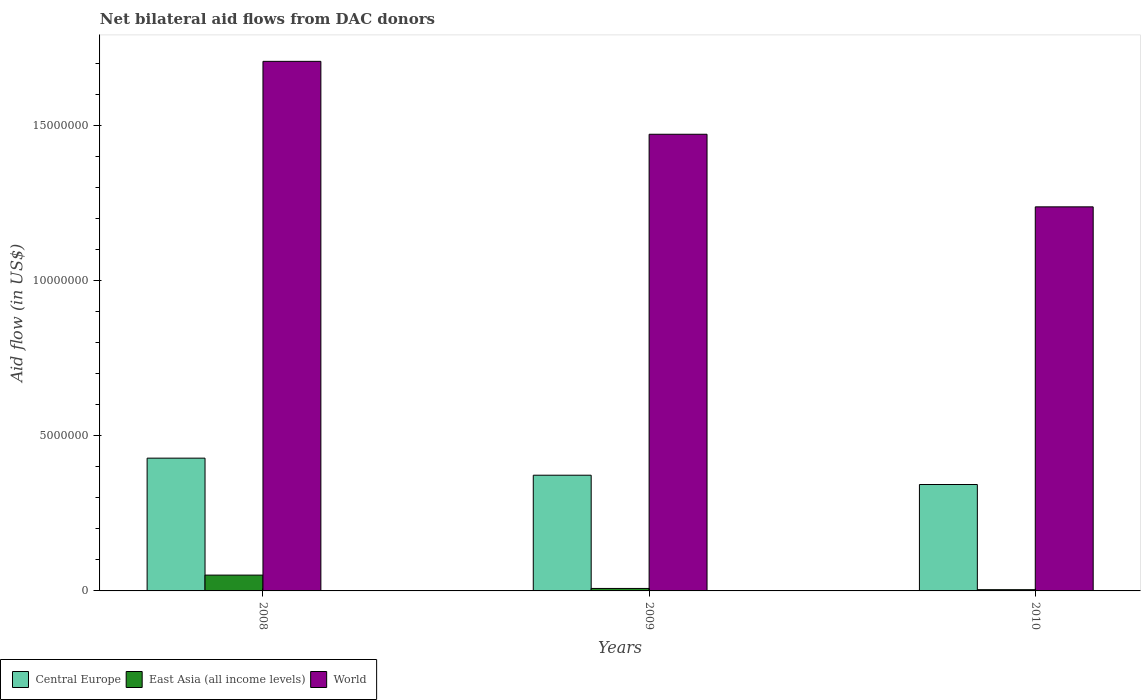How many different coloured bars are there?
Your response must be concise. 3. How many groups of bars are there?
Provide a succinct answer. 3. Are the number of bars per tick equal to the number of legend labels?
Give a very brief answer. Yes. Are the number of bars on each tick of the X-axis equal?
Make the answer very short. Yes. How many bars are there on the 3rd tick from the right?
Your response must be concise. 3. What is the label of the 2nd group of bars from the left?
Your answer should be very brief. 2009. What is the net bilateral aid flow in East Asia (all income levels) in 2008?
Keep it short and to the point. 5.10e+05. Across all years, what is the maximum net bilateral aid flow in Central Europe?
Provide a short and direct response. 4.28e+06. Across all years, what is the minimum net bilateral aid flow in East Asia (all income levels)?
Offer a very short reply. 4.00e+04. What is the total net bilateral aid flow in East Asia (all income levels) in the graph?
Offer a terse response. 6.30e+05. What is the difference between the net bilateral aid flow in Central Europe in 2009 and that in 2010?
Offer a very short reply. 3.00e+05. What is the difference between the net bilateral aid flow in Central Europe in 2010 and the net bilateral aid flow in World in 2009?
Your answer should be very brief. -1.13e+07. In the year 2009, what is the difference between the net bilateral aid flow in World and net bilateral aid flow in Central Europe?
Provide a short and direct response. 1.10e+07. In how many years, is the net bilateral aid flow in World greater than 2000000 US$?
Provide a succinct answer. 3. What is the ratio of the net bilateral aid flow in Central Europe in 2008 to that in 2009?
Offer a very short reply. 1.15. What is the difference between the highest and the second highest net bilateral aid flow in Central Europe?
Ensure brevity in your answer.  5.50e+05. What is the difference between the highest and the lowest net bilateral aid flow in World?
Offer a very short reply. 4.69e+06. In how many years, is the net bilateral aid flow in Central Europe greater than the average net bilateral aid flow in Central Europe taken over all years?
Provide a short and direct response. 1. Is the sum of the net bilateral aid flow in East Asia (all income levels) in 2009 and 2010 greater than the maximum net bilateral aid flow in World across all years?
Offer a terse response. No. What does the 1st bar from the left in 2010 represents?
Give a very brief answer. Central Europe. What does the 3rd bar from the right in 2009 represents?
Offer a terse response. Central Europe. Is it the case that in every year, the sum of the net bilateral aid flow in World and net bilateral aid flow in East Asia (all income levels) is greater than the net bilateral aid flow in Central Europe?
Give a very brief answer. Yes. How many bars are there?
Your answer should be very brief. 9. Are all the bars in the graph horizontal?
Your answer should be compact. No. How many years are there in the graph?
Your answer should be very brief. 3. What is the difference between two consecutive major ticks on the Y-axis?
Your answer should be compact. 5.00e+06. Does the graph contain any zero values?
Keep it short and to the point. No. Does the graph contain grids?
Your answer should be compact. No. What is the title of the graph?
Your response must be concise. Net bilateral aid flows from DAC donors. What is the label or title of the Y-axis?
Make the answer very short. Aid flow (in US$). What is the Aid flow (in US$) in Central Europe in 2008?
Provide a short and direct response. 4.28e+06. What is the Aid flow (in US$) of East Asia (all income levels) in 2008?
Make the answer very short. 5.10e+05. What is the Aid flow (in US$) in World in 2008?
Provide a succinct answer. 1.71e+07. What is the Aid flow (in US$) in Central Europe in 2009?
Provide a short and direct response. 3.73e+06. What is the Aid flow (in US$) of East Asia (all income levels) in 2009?
Your answer should be very brief. 8.00e+04. What is the Aid flow (in US$) of World in 2009?
Ensure brevity in your answer.  1.47e+07. What is the Aid flow (in US$) in Central Europe in 2010?
Your response must be concise. 3.43e+06. What is the Aid flow (in US$) of World in 2010?
Offer a very short reply. 1.24e+07. Across all years, what is the maximum Aid flow (in US$) of Central Europe?
Provide a succinct answer. 4.28e+06. Across all years, what is the maximum Aid flow (in US$) in East Asia (all income levels)?
Offer a terse response. 5.10e+05. Across all years, what is the maximum Aid flow (in US$) of World?
Your answer should be compact. 1.71e+07. Across all years, what is the minimum Aid flow (in US$) in Central Europe?
Ensure brevity in your answer.  3.43e+06. Across all years, what is the minimum Aid flow (in US$) of East Asia (all income levels)?
Make the answer very short. 4.00e+04. Across all years, what is the minimum Aid flow (in US$) of World?
Offer a terse response. 1.24e+07. What is the total Aid flow (in US$) of Central Europe in the graph?
Make the answer very short. 1.14e+07. What is the total Aid flow (in US$) of East Asia (all income levels) in the graph?
Provide a succinct answer. 6.30e+05. What is the total Aid flow (in US$) of World in the graph?
Make the answer very short. 4.42e+07. What is the difference between the Aid flow (in US$) in Central Europe in 2008 and that in 2009?
Make the answer very short. 5.50e+05. What is the difference between the Aid flow (in US$) of East Asia (all income levels) in 2008 and that in 2009?
Your answer should be compact. 4.30e+05. What is the difference between the Aid flow (in US$) of World in 2008 and that in 2009?
Provide a succinct answer. 2.35e+06. What is the difference between the Aid flow (in US$) in Central Europe in 2008 and that in 2010?
Offer a very short reply. 8.50e+05. What is the difference between the Aid flow (in US$) in World in 2008 and that in 2010?
Give a very brief answer. 4.69e+06. What is the difference between the Aid flow (in US$) of Central Europe in 2009 and that in 2010?
Offer a terse response. 3.00e+05. What is the difference between the Aid flow (in US$) in World in 2009 and that in 2010?
Keep it short and to the point. 2.34e+06. What is the difference between the Aid flow (in US$) of Central Europe in 2008 and the Aid flow (in US$) of East Asia (all income levels) in 2009?
Offer a very short reply. 4.20e+06. What is the difference between the Aid flow (in US$) in Central Europe in 2008 and the Aid flow (in US$) in World in 2009?
Offer a terse response. -1.04e+07. What is the difference between the Aid flow (in US$) of East Asia (all income levels) in 2008 and the Aid flow (in US$) of World in 2009?
Offer a terse response. -1.42e+07. What is the difference between the Aid flow (in US$) in Central Europe in 2008 and the Aid flow (in US$) in East Asia (all income levels) in 2010?
Make the answer very short. 4.24e+06. What is the difference between the Aid flow (in US$) of Central Europe in 2008 and the Aid flow (in US$) of World in 2010?
Give a very brief answer. -8.10e+06. What is the difference between the Aid flow (in US$) in East Asia (all income levels) in 2008 and the Aid flow (in US$) in World in 2010?
Make the answer very short. -1.19e+07. What is the difference between the Aid flow (in US$) in Central Europe in 2009 and the Aid flow (in US$) in East Asia (all income levels) in 2010?
Your answer should be very brief. 3.69e+06. What is the difference between the Aid flow (in US$) of Central Europe in 2009 and the Aid flow (in US$) of World in 2010?
Keep it short and to the point. -8.65e+06. What is the difference between the Aid flow (in US$) of East Asia (all income levels) in 2009 and the Aid flow (in US$) of World in 2010?
Your answer should be compact. -1.23e+07. What is the average Aid flow (in US$) of Central Europe per year?
Your answer should be compact. 3.81e+06. What is the average Aid flow (in US$) in World per year?
Offer a terse response. 1.47e+07. In the year 2008, what is the difference between the Aid flow (in US$) of Central Europe and Aid flow (in US$) of East Asia (all income levels)?
Your answer should be very brief. 3.77e+06. In the year 2008, what is the difference between the Aid flow (in US$) in Central Europe and Aid flow (in US$) in World?
Provide a succinct answer. -1.28e+07. In the year 2008, what is the difference between the Aid flow (in US$) in East Asia (all income levels) and Aid flow (in US$) in World?
Make the answer very short. -1.66e+07. In the year 2009, what is the difference between the Aid flow (in US$) in Central Europe and Aid flow (in US$) in East Asia (all income levels)?
Your answer should be compact. 3.65e+06. In the year 2009, what is the difference between the Aid flow (in US$) of Central Europe and Aid flow (in US$) of World?
Offer a terse response. -1.10e+07. In the year 2009, what is the difference between the Aid flow (in US$) of East Asia (all income levels) and Aid flow (in US$) of World?
Keep it short and to the point. -1.46e+07. In the year 2010, what is the difference between the Aid flow (in US$) in Central Europe and Aid flow (in US$) in East Asia (all income levels)?
Your answer should be very brief. 3.39e+06. In the year 2010, what is the difference between the Aid flow (in US$) in Central Europe and Aid flow (in US$) in World?
Keep it short and to the point. -8.95e+06. In the year 2010, what is the difference between the Aid flow (in US$) in East Asia (all income levels) and Aid flow (in US$) in World?
Keep it short and to the point. -1.23e+07. What is the ratio of the Aid flow (in US$) of Central Europe in 2008 to that in 2009?
Provide a short and direct response. 1.15. What is the ratio of the Aid flow (in US$) of East Asia (all income levels) in 2008 to that in 2009?
Your answer should be very brief. 6.38. What is the ratio of the Aid flow (in US$) in World in 2008 to that in 2009?
Your response must be concise. 1.16. What is the ratio of the Aid flow (in US$) of Central Europe in 2008 to that in 2010?
Your response must be concise. 1.25. What is the ratio of the Aid flow (in US$) in East Asia (all income levels) in 2008 to that in 2010?
Keep it short and to the point. 12.75. What is the ratio of the Aid flow (in US$) of World in 2008 to that in 2010?
Your answer should be compact. 1.38. What is the ratio of the Aid flow (in US$) of Central Europe in 2009 to that in 2010?
Give a very brief answer. 1.09. What is the ratio of the Aid flow (in US$) in East Asia (all income levels) in 2009 to that in 2010?
Ensure brevity in your answer.  2. What is the ratio of the Aid flow (in US$) of World in 2009 to that in 2010?
Offer a terse response. 1.19. What is the difference between the highest and the second highest Aid flow (in US$) of World?
Provide a succinct answer. 2.35e+06. What is the difference between the highest and the lowest Aid flow (in US$) in Central Europe?
Offer a terse response. 8.50e+05. What is the difference between the highest and the lowest Aid flow (in US$) of World?
Offer a very short reply. 4.69e+06. 